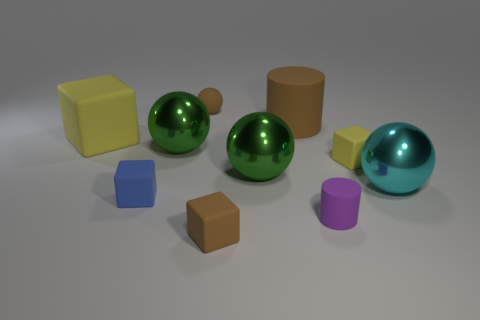Subtract all brown balls. How many balls are left? 3 Subtract all cyan balls. How many yellow blocks are left? 2 Subtract all brown balls. How many balls are left? 3 Subtract 2 blocks. How many blocks are left? 2 Subtract all blue cylinders. Subtract all cyan blocks. How many cylinders are left? 2 Subtract all balls. How many objects are left? 6 Subtract 0 red balls. How many objects are left? 10 Subtract all small blue rubber blocks. Subtract all tiny brown cubes. How many objects are left? 8 Add 4 big yellow blocks. How many big yellow blocks are left? 5 Add 1 large matte objects. How many large matte objects exist? 3 